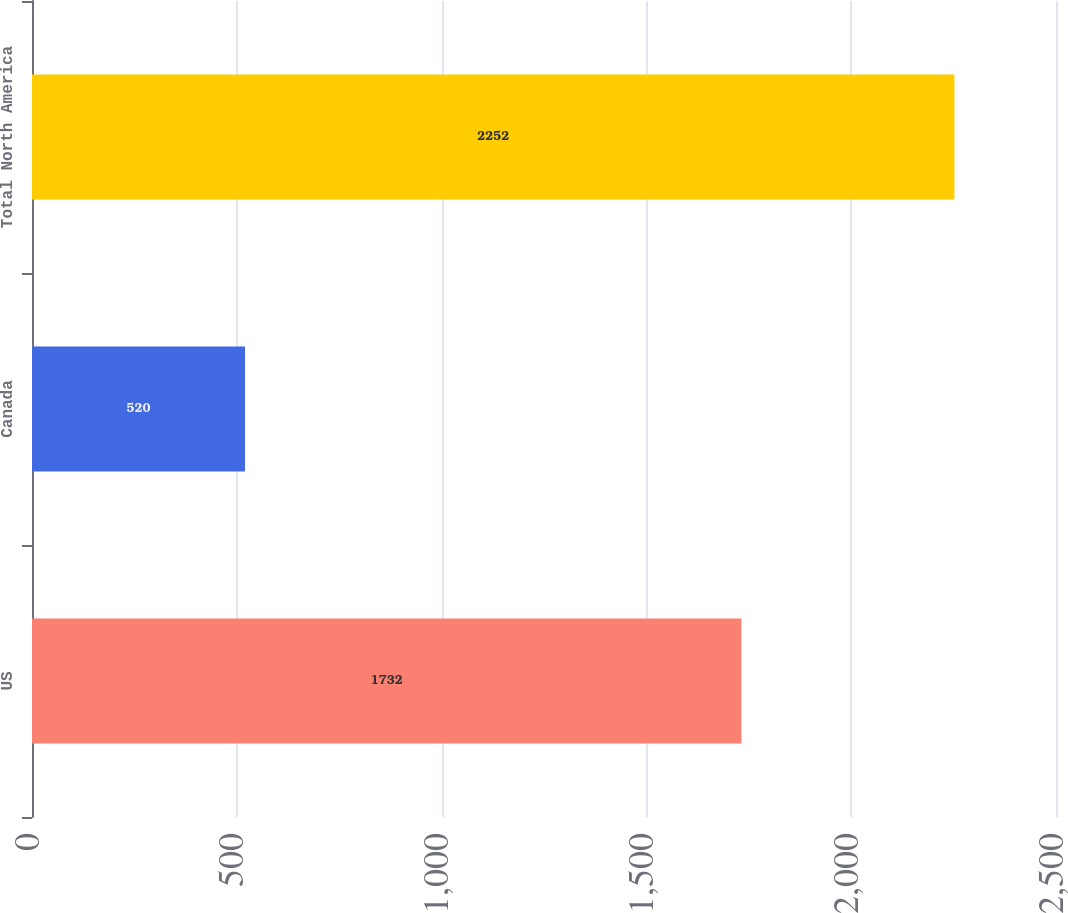<chart> <loc_0><loc_0><loc_500><loc_500><bar_chart><fcel>US<fcel>Canada<fcel>Total North America<nl><fcel>1732<fcel>520<fcel>2252<nl></chart> 